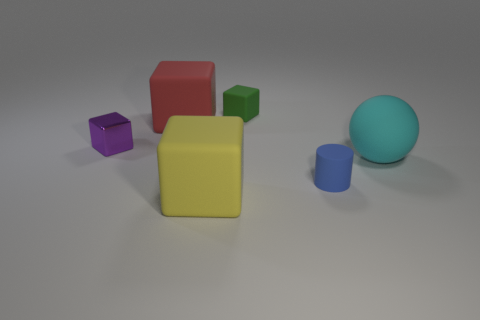Subtract all yellow cylinders. Subtract all red cubes. How many cylinders are left? 1 Add 3 big purple matte spheres. How many objects exist? 9 Subtract all balls. How many objects are left? 5 Subtract all large green shiny cylinders. Subtract all large things. How many objects are left? 3 Add 1 spheres. How many spheres are left? 2 Add 4 tiny brown things. How many tiny brown things exist? 4 Subtract 0 purple balls. How many objects are left? 6 